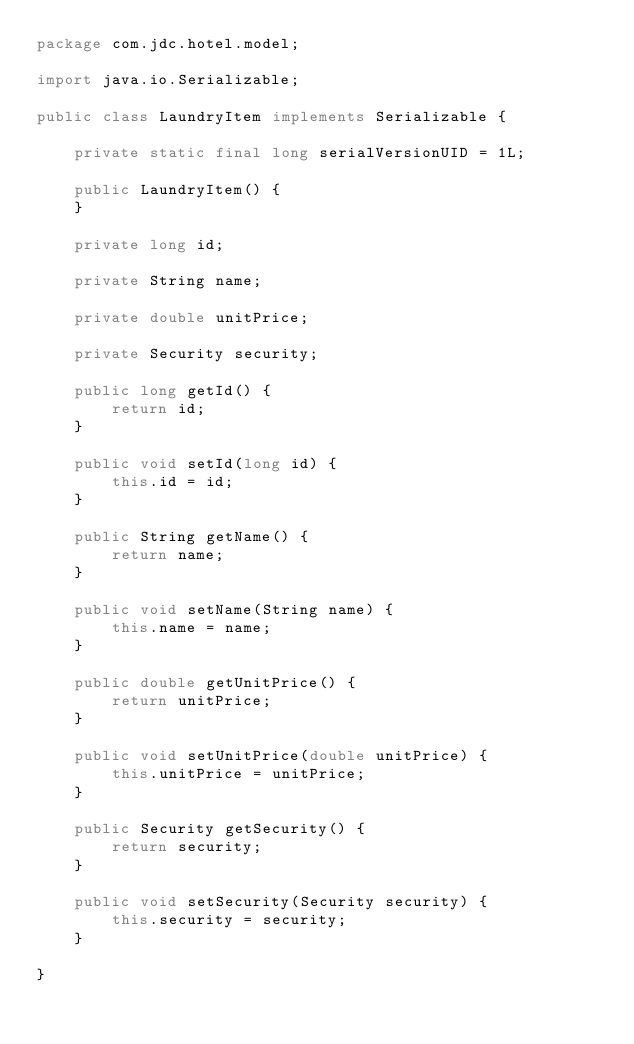<code> <loc_0><loc_0><loc_500><loc_500><_Java_>package com.jdc.hotel.model;

import java.io.Serializable;

public class LaundryItem implements Serializable {

	private static final long serialVersionUID = 1L;

	public LaundryItem() {
	}

	private long id;

	private String name;

	private double unitPrice;

	private Security security;

	public long getId() {
		return id;
	}

	public void setId(long id) {
		this.id = id;
	}

	public String getName() {
		return name;
	}

	public void setName(String name) {
		this.name = name;
	}

	public double getUnitPrice() {
		return unitPrice;
	}

	public void setUnitPrice(double unitPrice) {
		this.unitPrice = unitPrice;
	}

	public Security getSecurity() {
		return security;
	}

	public void setSecurity(Security security) {
		this.security = security;
	}

}</code> 